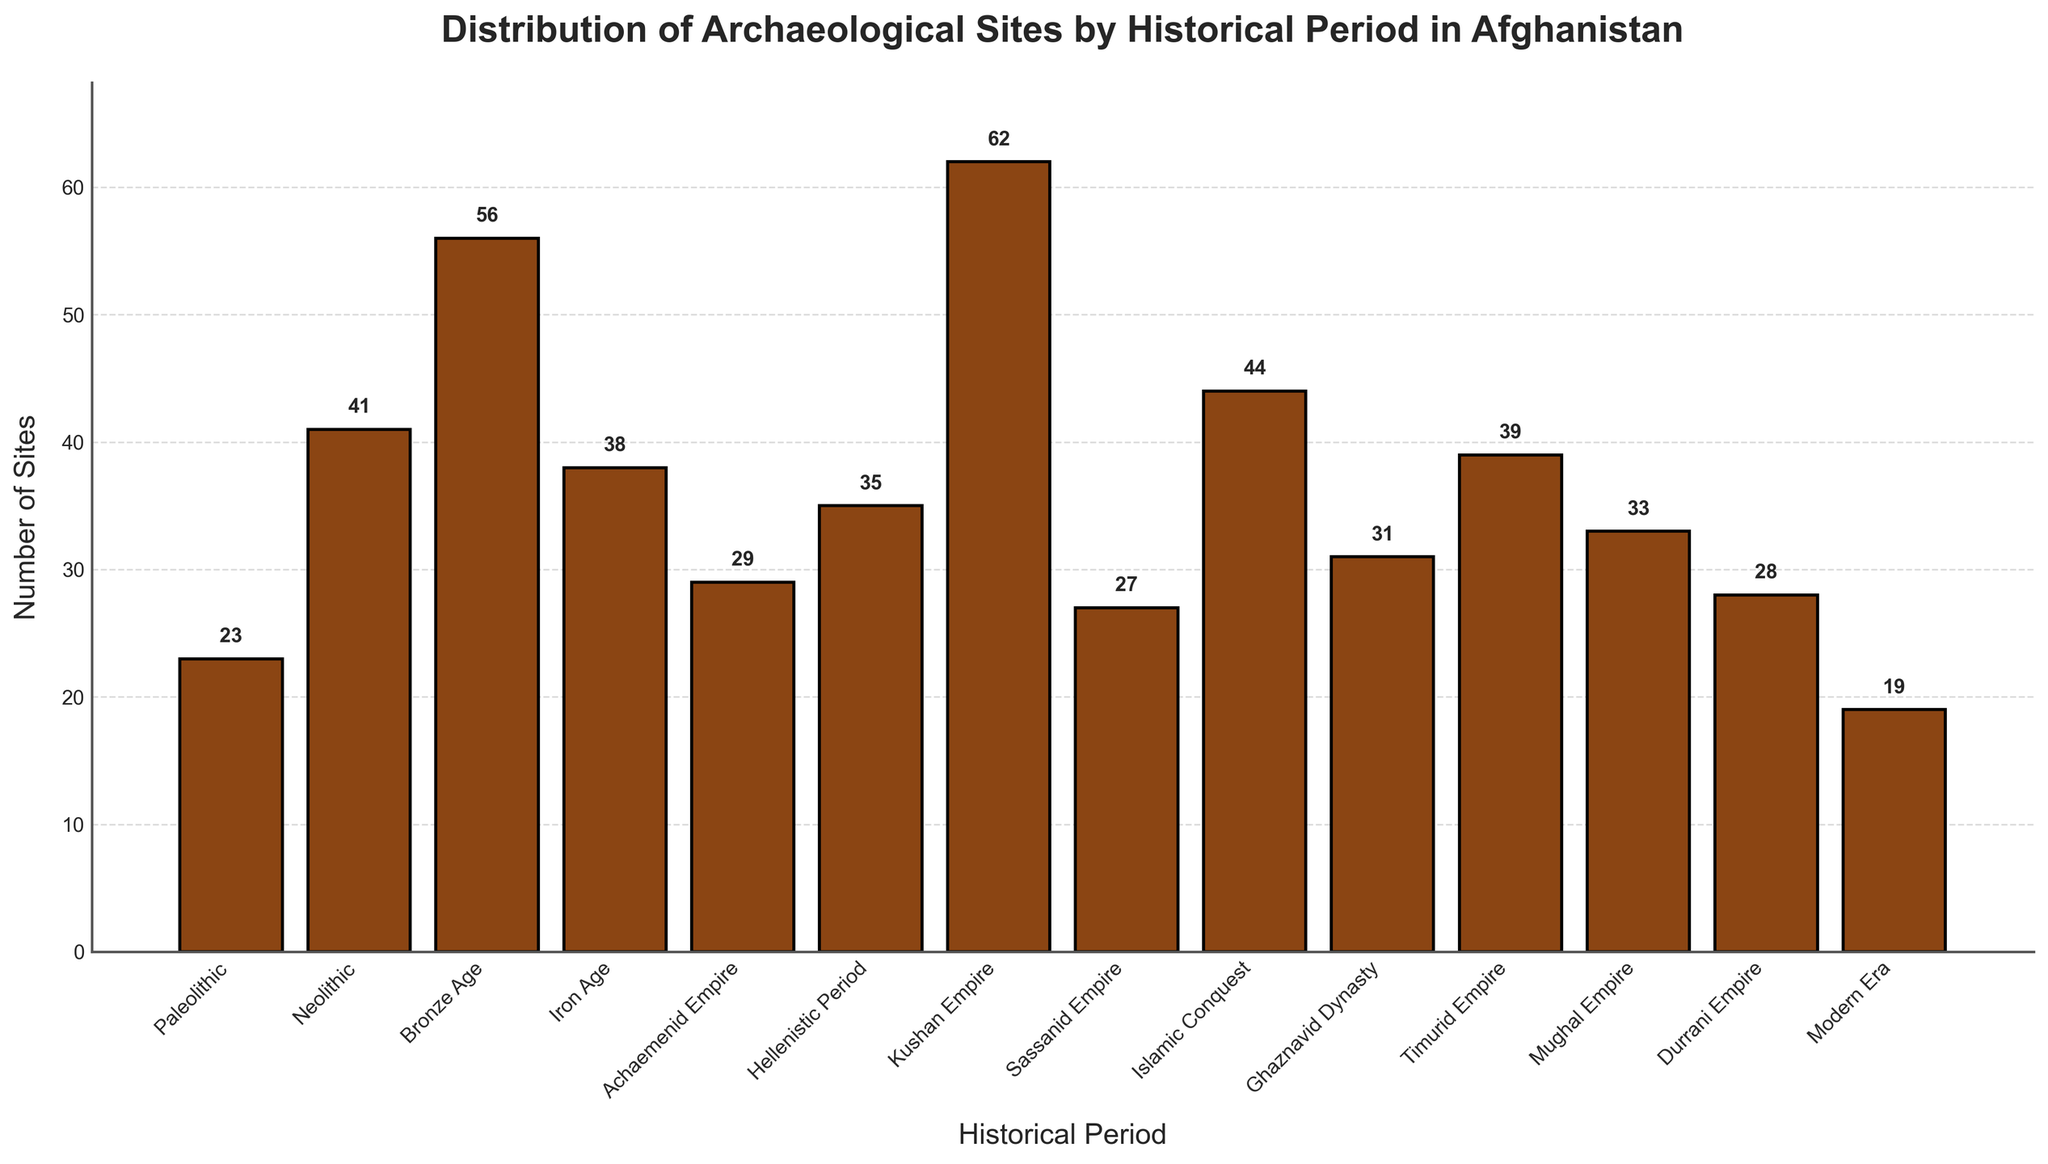What historical period has the highest number of archaeological sites in Afghanistan? Look at the height of the bars in the chart. The period with the highest bar is the Kushan Empire which has 62 sites.
Answer: Kushan Empire How many more sites are there in the Kushan Empire compared to the Modern Era? Compare the heights of the bars for the Kushan Empire and the Modern Era. The Kushan Empire has 62 sites and the Modern Era has 19 sites. The difference is 62 - 19 = 43 sites.
Answer: 43 Which two periods have the smallest difference in the number of sites? Check all the pairs of adjacent bars in the chart to find the smallest numerical difference. The smallest difference is between the Durrani Empire (28 sites) and the Sassanid Empire (27 sites), which is 1 site.
Answer: Durrani Empire and Sassanid Empire What is the total number of archaeological sites from the Timurid Empire, Mughal Empire, and Durrani Empire combined? Add the number of sites from each period mentioned: Timurid Empire has 39 sites, Mughal Empire has 33 sites, and Durrani Empire has 28 sites. The total is 39 + 33 + 28 = 100.
Answer: 100 During which period(s) are the number of sites more than 40 but less than 50? Look for bars that are higher than 40 but shorter than 50. The periods are Islamic Conquest (44 sites) and Neolithic (41 sites).
Answer: Islamic Conquest and Neolithic What is the average number of archaeological sites across all periods? Sum all the site numbers and divide by the number of periods. The total number of sites is 23 + 41 + 56 + 38 + 29 + 35 + 62 + 27 + 44 + 31 + 39 + 33 + 28 + 19 = 505. There are 14 periods. So, the average is 505 / 14 ≈ 36.07.
Answer: 36.07 Which two historical periods together account for the highest number of archaeological sites? Identify the bars with the highest and second-highest values. The Kushan Empire (62 sites) and Bronze Age (56 sites) combined have 62 + 56 = 118 sites.
Answer: Kushan Empire and Bronze Age How does the number of sites in the Iron Age compare to that of the Hellenistic Period? Compare the heights of the bars for the Iron Age and Hellenistic Period. Iron Age has 38 sites and Hellenistic Period has 35 sites. So, Iron Age has 3 more sites than the Hellenistic Period.
Answer: Iron Age has 3 more sites What percentage of the total sites are from the Bronze Age? Find the total number of sites and calculate the percentage. The total number of sites is 505. The Bronze Age has 56 sites. The percentage is (56 / 505) * 100 ≈ 11.09%.
Answer: 11.09% Which period shows the least number of archaeological sites, and how many are there? Identify the shortest bar in the chart. The Modern Era has the least number of sites, which is 19.
Answer: Modern Era, 19 